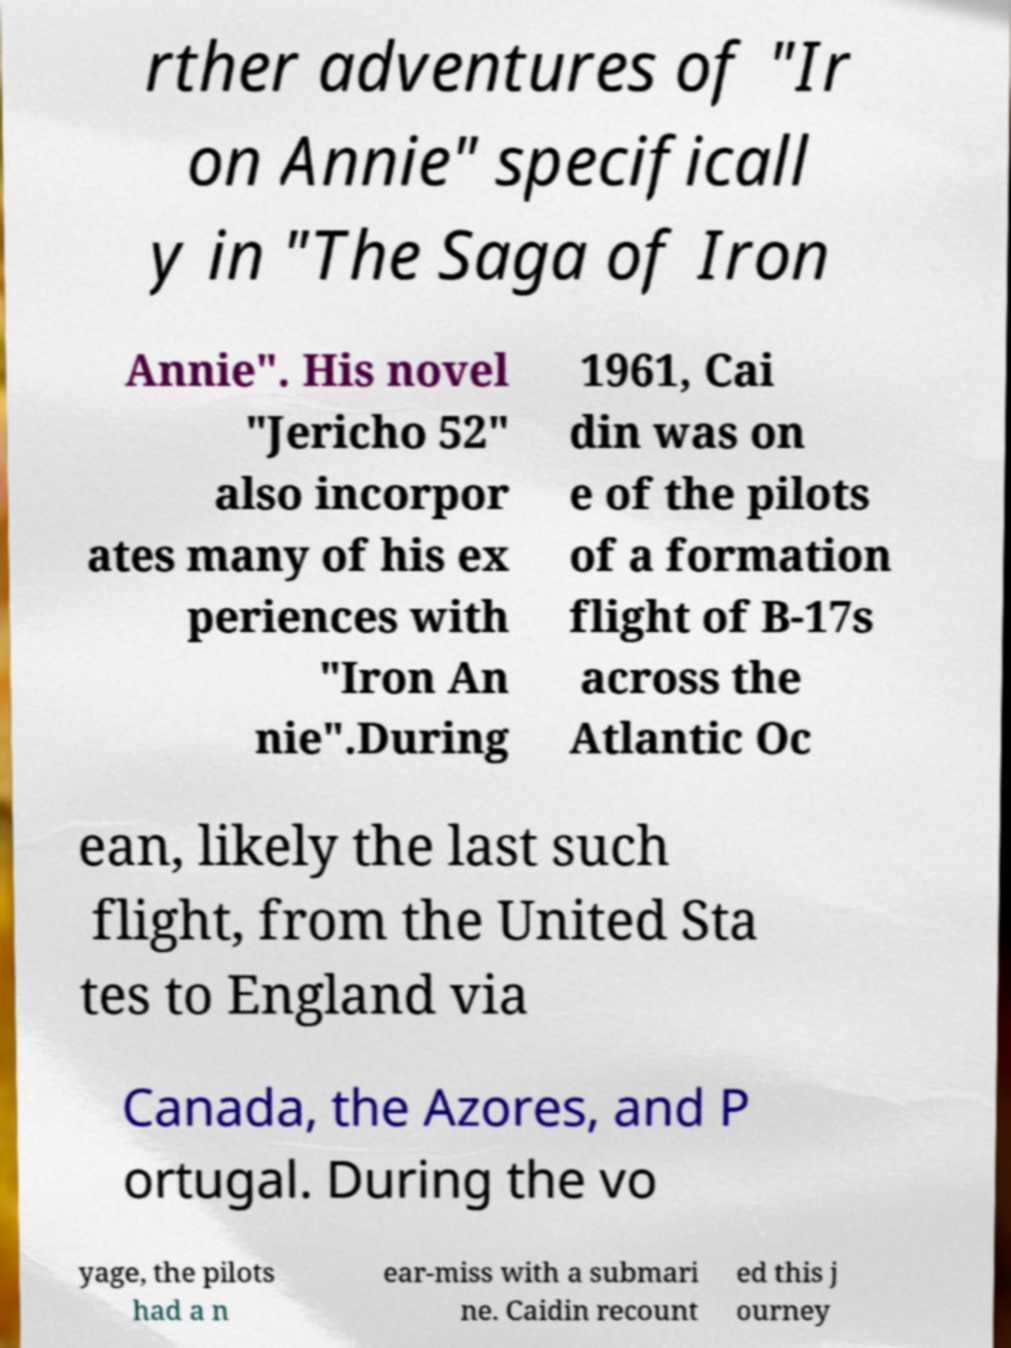Could you extract and type out the text from this image? rther adventures of "Ir on Annie" specificall y in "The Saga of Iron Annie". His novel "Jericho 52" also incorpor ates many of his ex periences with "Iron An nie".During 1961, Cai din was on e of the pilots of a formation flight of B-17s across the Atlantic Oc ean, likely the last such flight, from the United Sta tes to England via Canada, the Azores, and P ortugal. During the vo yage, the pilots had a n ear-miss with a submari ne. Caidin recount ed this j ourney 